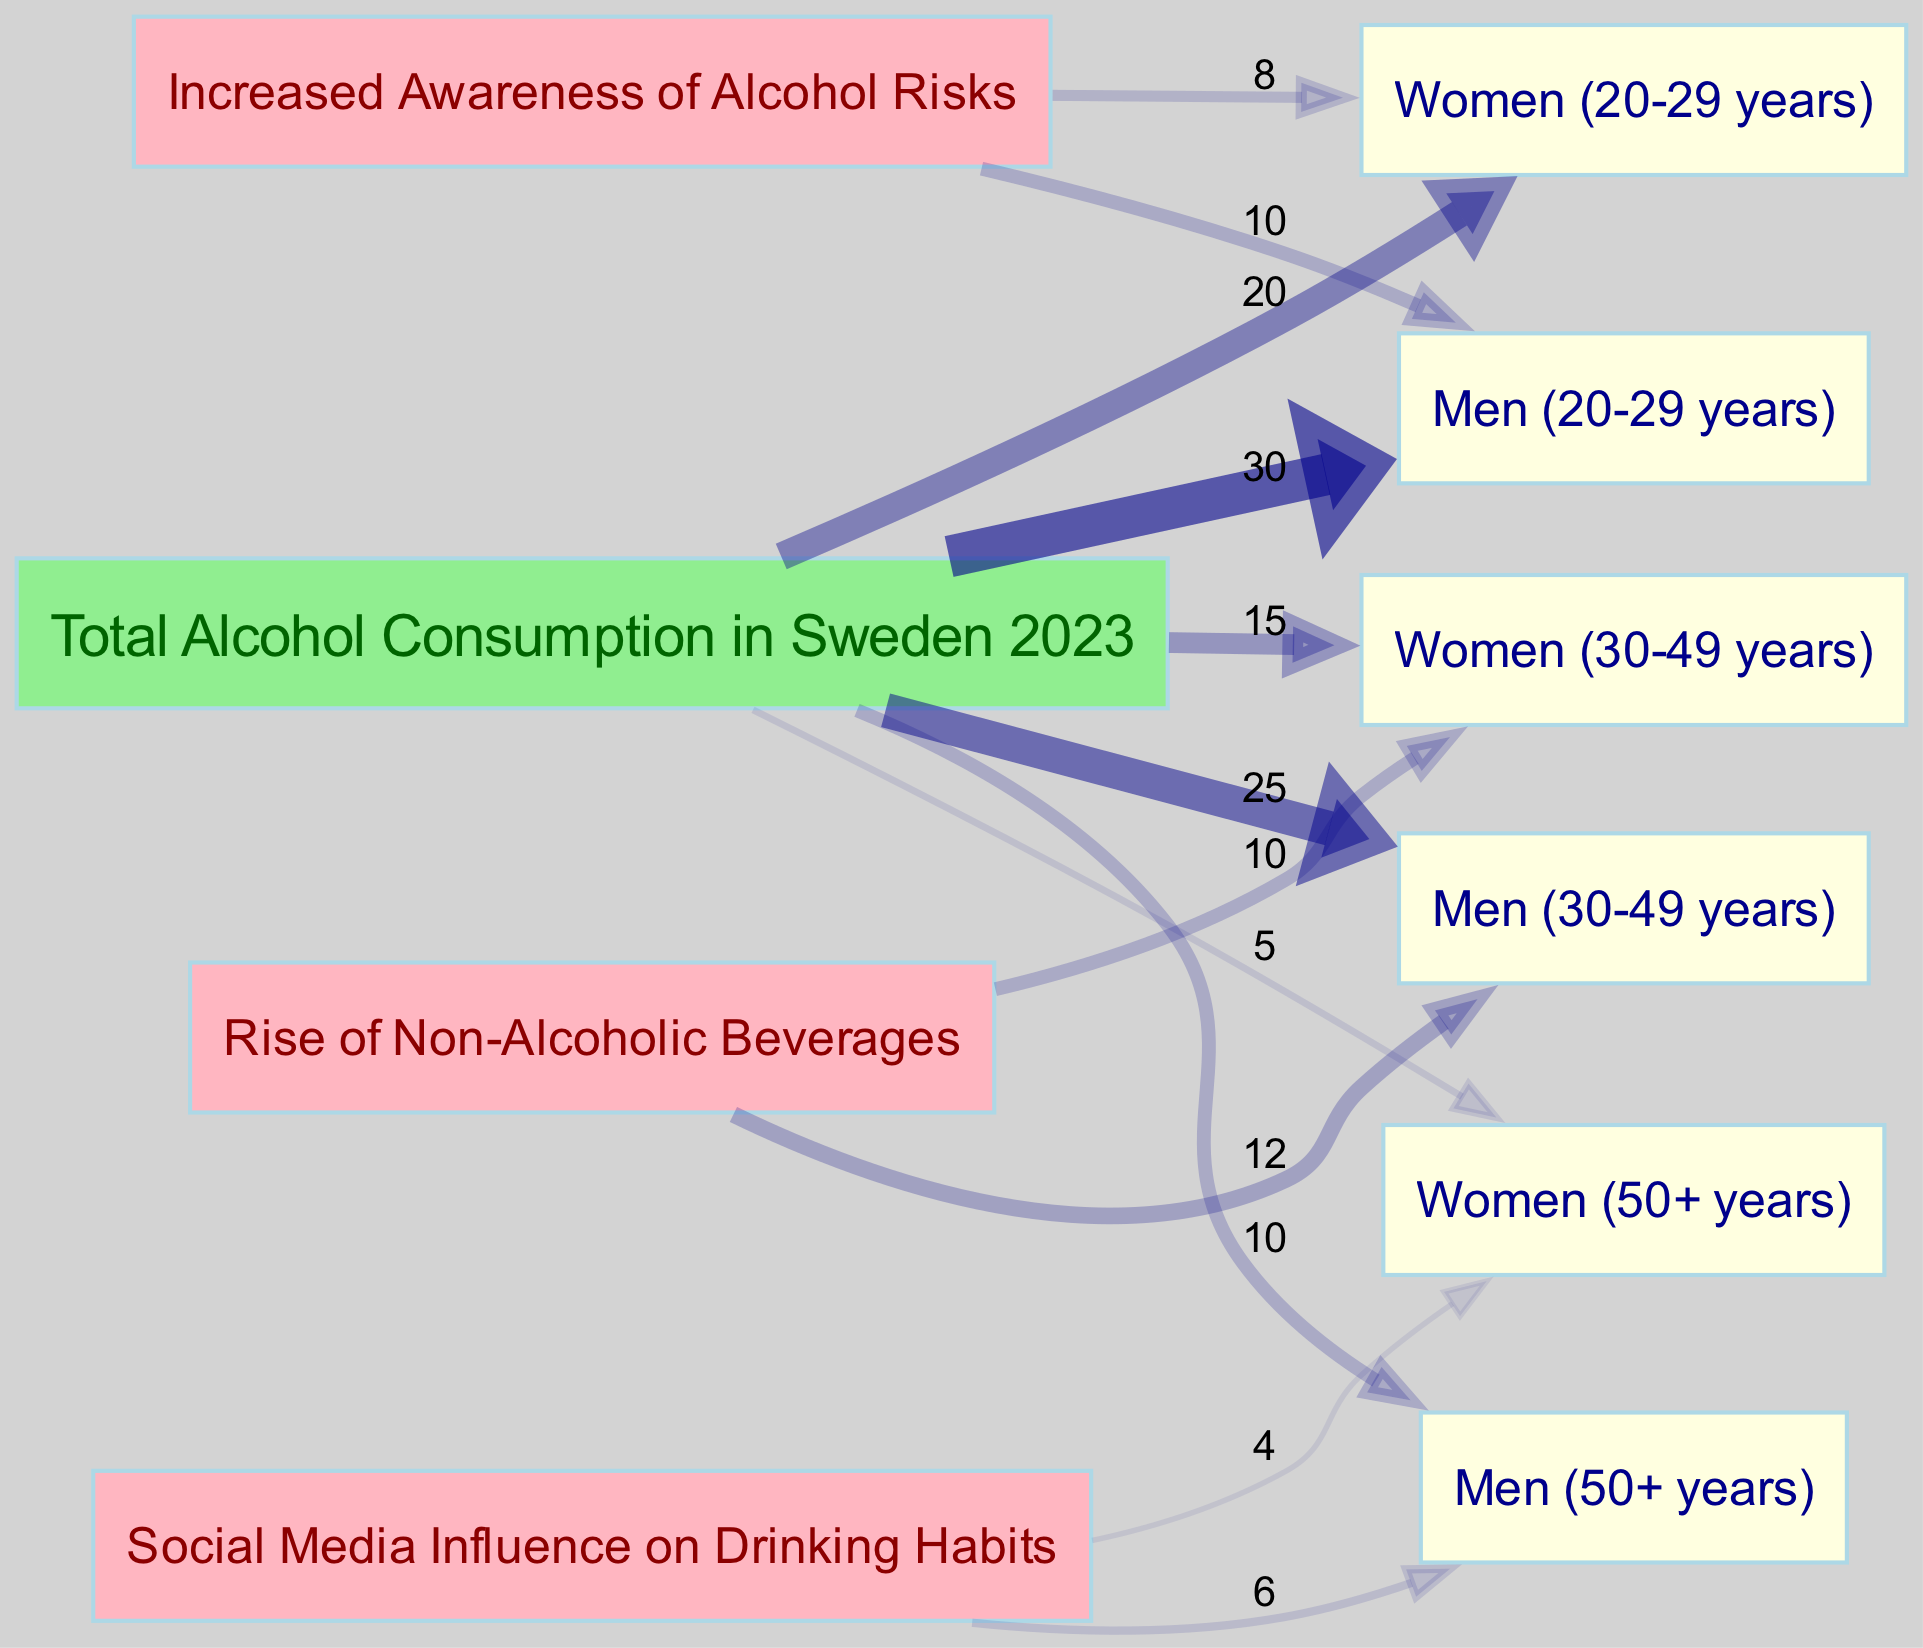What is the total alcohol consumption rate for Men aged 20-29? The diagram shows a direct link from "Total Alcohol Consumption in Sweden 2023" to "Men (20-29 years)" with a value of 30.
Answer: 30 What is the total alcohol consumption rate for Women aged 50+? The diagram indicates a direct link from "Total Alcohol Consumption in Sweden 2023" to "Women (50+ years)" with a value of 5.
Answer: 5 How many total demographic groups are represented in the diagram? By counting the distinct demographic nodes, there are six groups: Men (20-29 years), Women (20-29 years), Men (30-49 years), Women (30-49 years), Men (50+ years), and Women (50+ years).
Answer: 6 Which demographic has the highest alcohol consumption rate? The highest consumption rate shown in the diagram is for "Men (20-29 years)" with a value of 30, indicating they consume more alcohol compared to other demographics.
Answer: Men (20-29 years) What is the value associated with the link from "Increased Awareness of Alcohol Risks" to Women aged 20-29? The diagram shows a connection from "Increased Awareness of Alcohol Risks" to "Women (20-29 years)" with a value of 8.
Answer: 8 Which societal attitude influences Men aged 30-49 years' alcohol consumption the most? The highest value from "Rise of Non-Alcoholic Beverages" to "Men (30-49 years)" is 12, indicating it has the most influence on their consumption habits.
Answer: Rise of Non-Alcoholic Beverages How do the attitudes towards drinking differ between Men aged 50+ and Women aged 50+? The diagram shows that "Social Media Influence on Drinking Habits" is the only influence linked to both demographics, with values of 6 for Men and 4 for Women, showing a disparity in how each demographic is affected.
Answer: Men aged 50+ have a higher influence What is the total alcohol consumption value for all Women aged 30-49 years? Adding the value for "Women (30-49 years)" from the consumption link, we see it is 15, reflecting their total alcohol consumption.
Answer: 15 How many societal attitudes are influencing the alcohol consumption rates illustrated in the diagram? There are three societal attitudes represented: "Increased Awareness of Alcohol Risks," "Rise of Non-Alcoholic Beverages," and "Social Media Influence on Drinking Habits," showing diverse influences on alcohol consumption.
Answer: 3 What is the value flowing from "Social Media Influence on Drinking Habits" to Men aged 50+? The diagram indicates a value of 6 flowing from "Social Media Influence on Drinking Habits" to "Men (50+ years)," reflecting this specific influence.
Answer: 6 